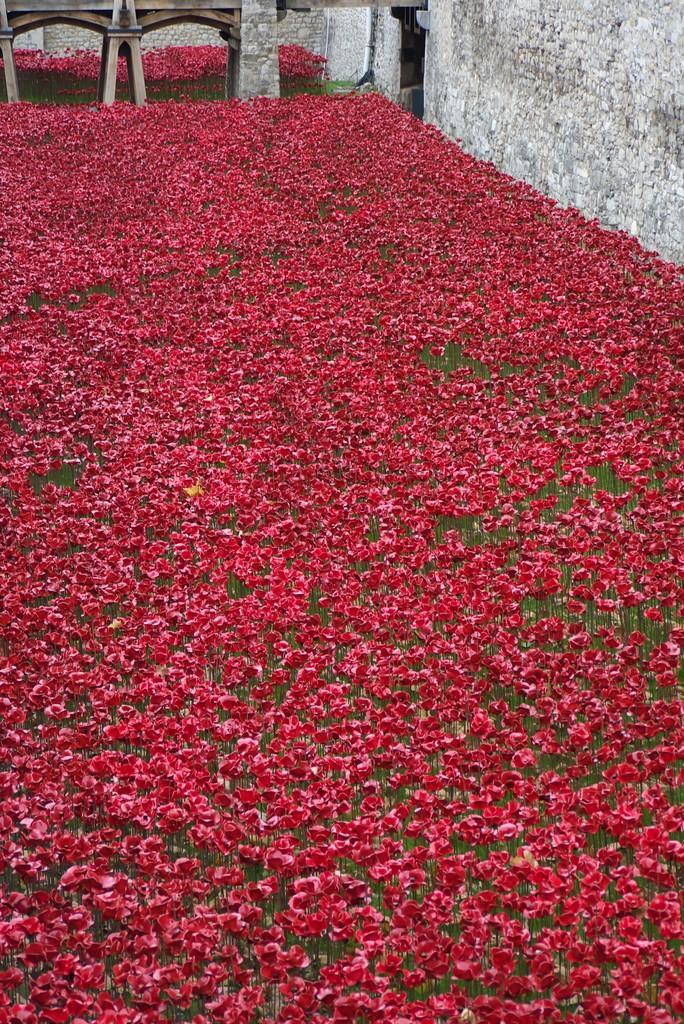How would you summarize this image in a sentence or two? Here we can see plants with red color flowers and in the background we can see a wall and an object on the wall. 